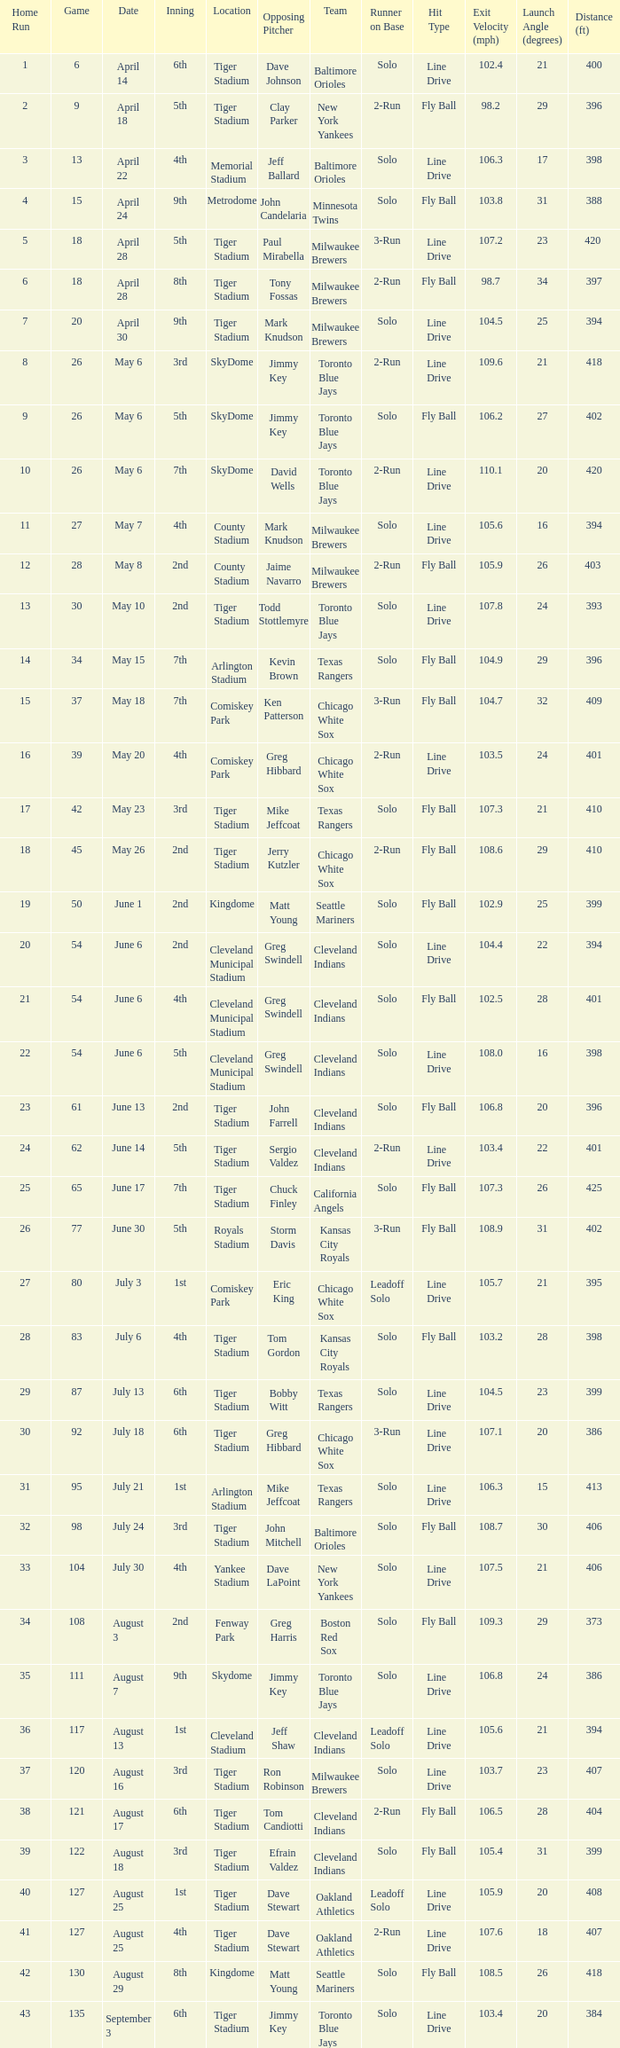When Efrain Valdez was pitching, what was the highest home run? 39.0. 